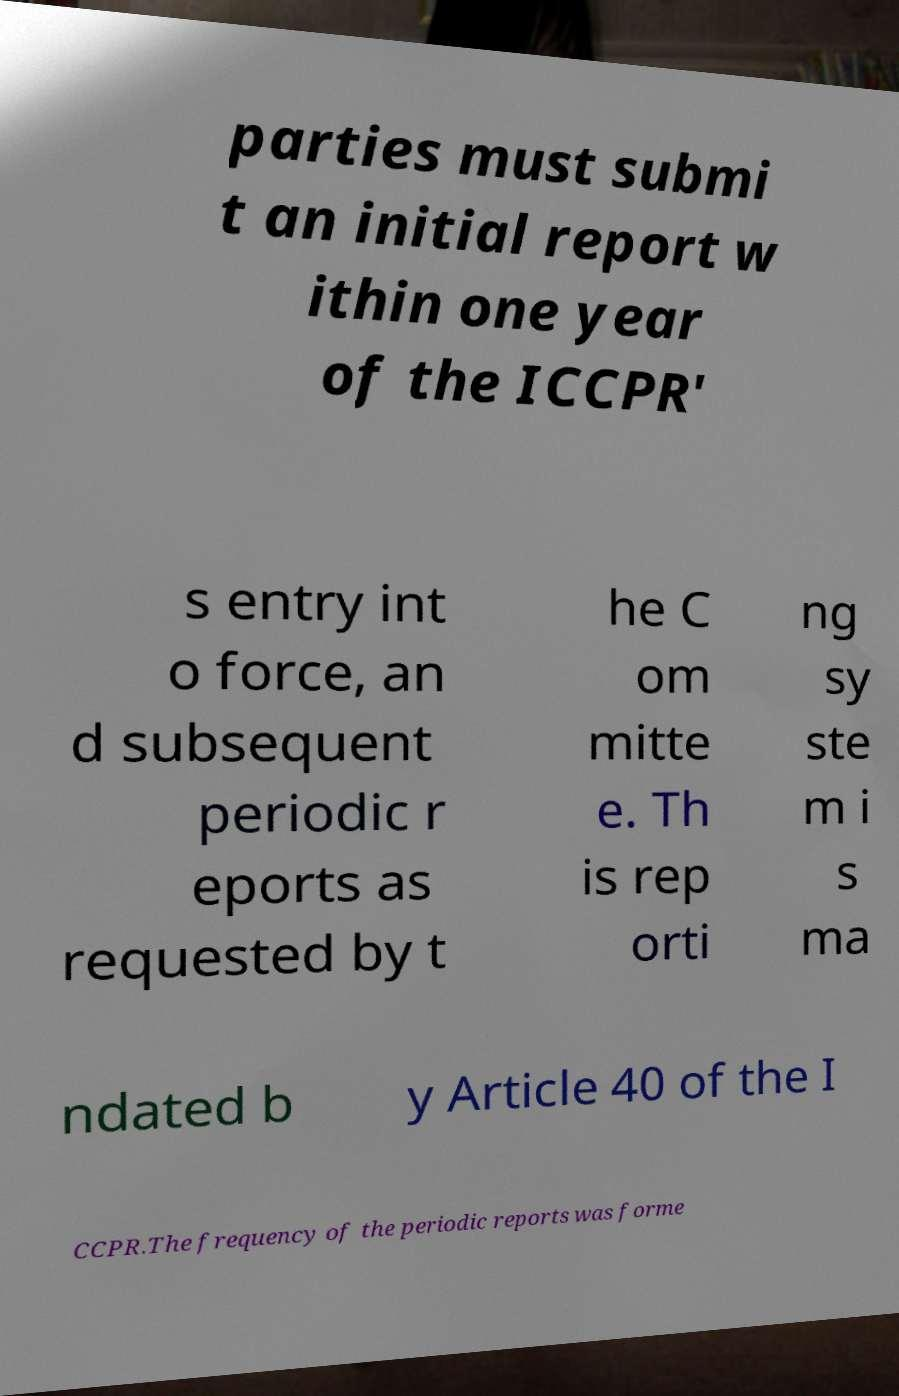Can you read and provide the text displayed in the image?This photo seems to have some interesting text. Can you extract and type it out for me? parties must submi t an initial report w ithin one year of the ICCPR' s entry int o force, an d subsequent periodic r eports as requested by t he C om mitte e. Th is rep orti ng sy ste m i s ma ndated b y Article 40 of the I CCPR.The frequency of the periodic reports was forme 